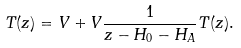Convert formula to latex. <formula><loc_0><loc_0><loc_500><loc_500>T ( z ) = V + V \frac { 1 } { z - H _ { 0 } - H _ { A } } T ( z ) .</formula> 